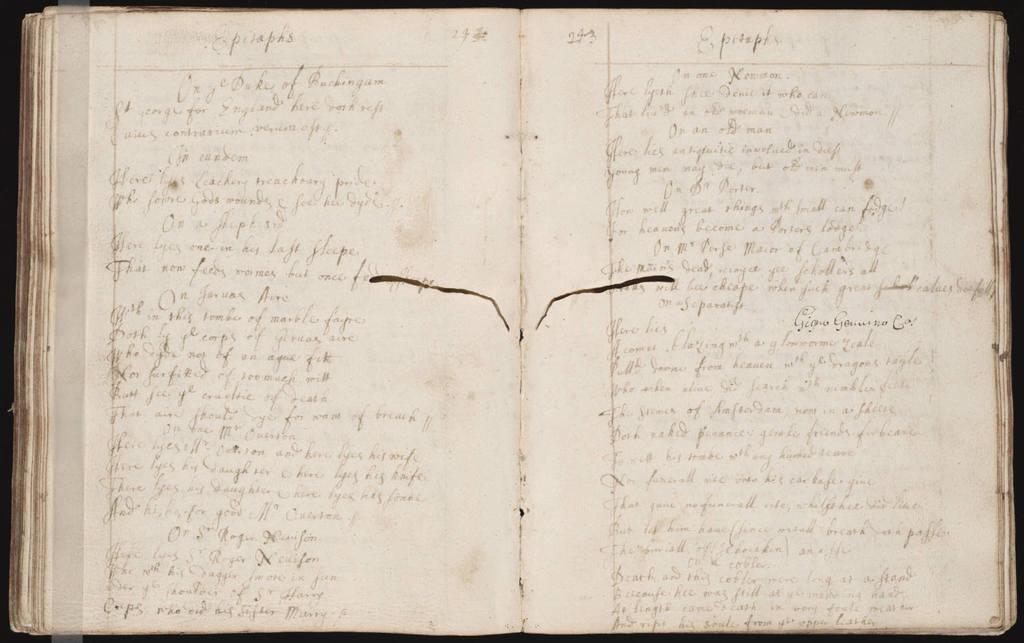What is the page number on the right?
Make the answer very short. 243. 